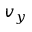Convert formula to latex. <formula><loc_0><loc_0><loc_500><loc_500>v _ { y }</formula> 